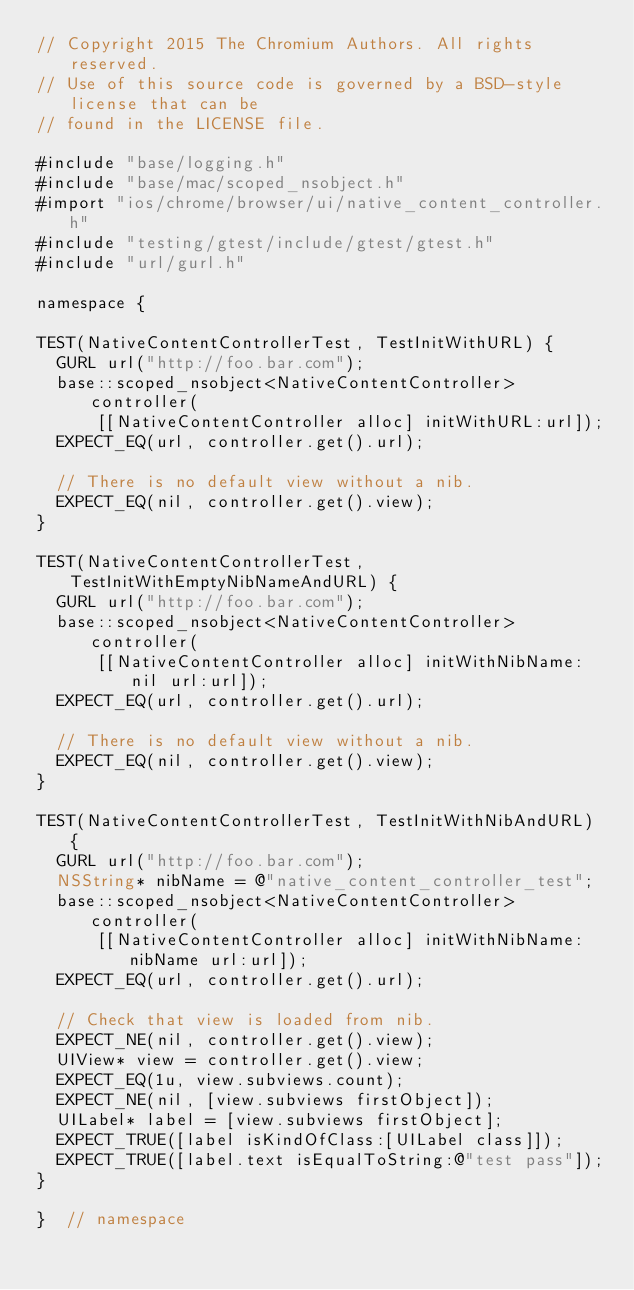Convert code to text. <code><loc_0><loc_0><loc_500><loc_500><_ObjectiveC_>// Copyright 2015 The Chromium Authors. All rights reserved.
// Use of this source code is governed by a BSD-style license that can be
// found in the LICENSE file.

#include "base/logging.h"
#include "base/mac/scoped_nsobject.h"
#import "ios/chrome/browser/ui/native_content_controller.h"
#include "testing/gtest/include/gtest/gtest.h"
#include "url/gurl.h"

namespace {

TEST(NativeContentControllerTest, TestInitWithURL) {
  GURL url("http://foo.bar.com");
  base::scoped_nsobject<NativeContentController> controller(
      [[NativeContentController alloc] initWithURL:url]);
  EXPECT_EQ(url, controller.get().url);

  // There is no default view without a nib.
  EXPECT_EQ(nil, controller.get().view);
}

TEST(NativeContentControllerTest, TestInitWithEmptyNibNameAndURL) {
  GURL url("http://foo.bar.com");
  base::scoped_nsobject<NativeContentController> controller(
      [[NativeContentController alloc] initWithNibName:nil url:url]);
  EXPECT_EQ(url, controller.get().url);

  // There is no default view without a nib.
  EXPECT_EQ(nil, controller.get().view);
}

TEST(NativeContentControllerTest, TestInitWithNibAndURL) {
  GURL url("http://foo.bar.com");
  NSString* nibName = @"native_content_controller_test";
  base::scoped_nsobject<NativeContentController> controller(
      [[NativeContentController alloc] initWithNibName:nibName url:url]);
  EXPECT_EQ(url, controller.get().url);

  // Check that view is loaded from nib.
  EXPECT_NE(nil, controller.get().view);
  UIView* view = controller.get().view;
  EXPECT_EQ(1u, view.subviews.count);
  EXPECT_NE(nil, [view.subviews firstObject]);
  UILabel* label = [view.subviews firstObject];
  EXPECT_TRUE([label isKindOfClass:[UILabel class]]);
  EXPECT_TRUE([label.text isEqualToString:@"test pass"]);
}

}  // namespace
</code> 